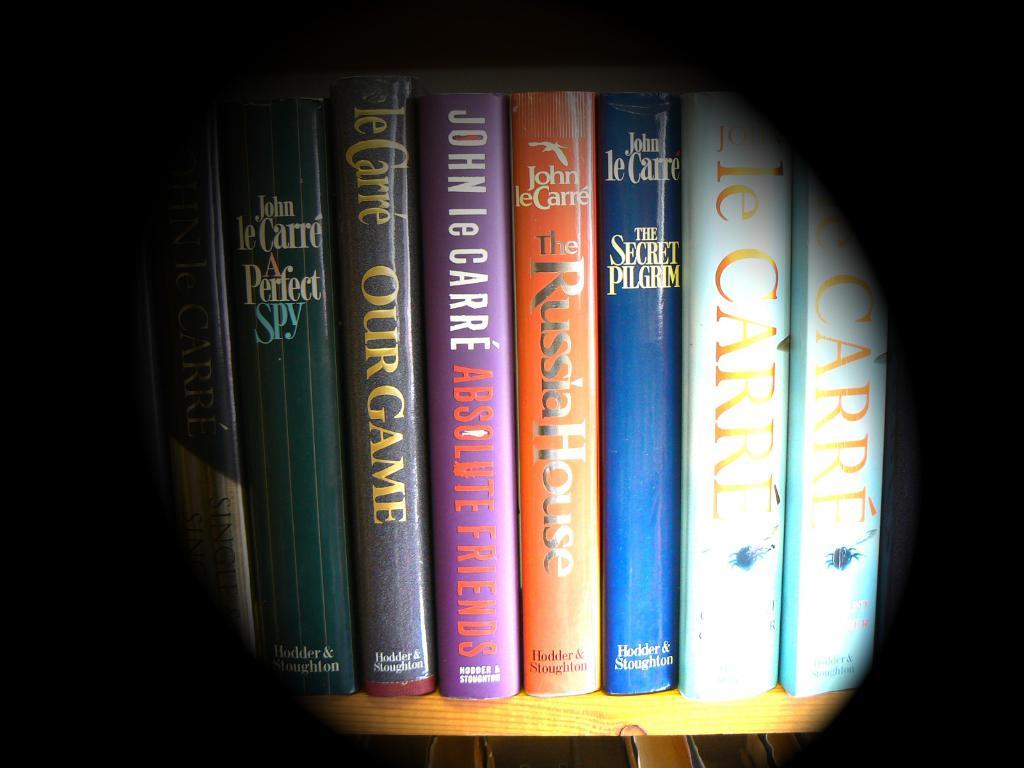Who wrote the orange book?
Offer a terse response. John le carre. What is the title of the book on the left?
Provide a short and direct response. A perfect spy. 